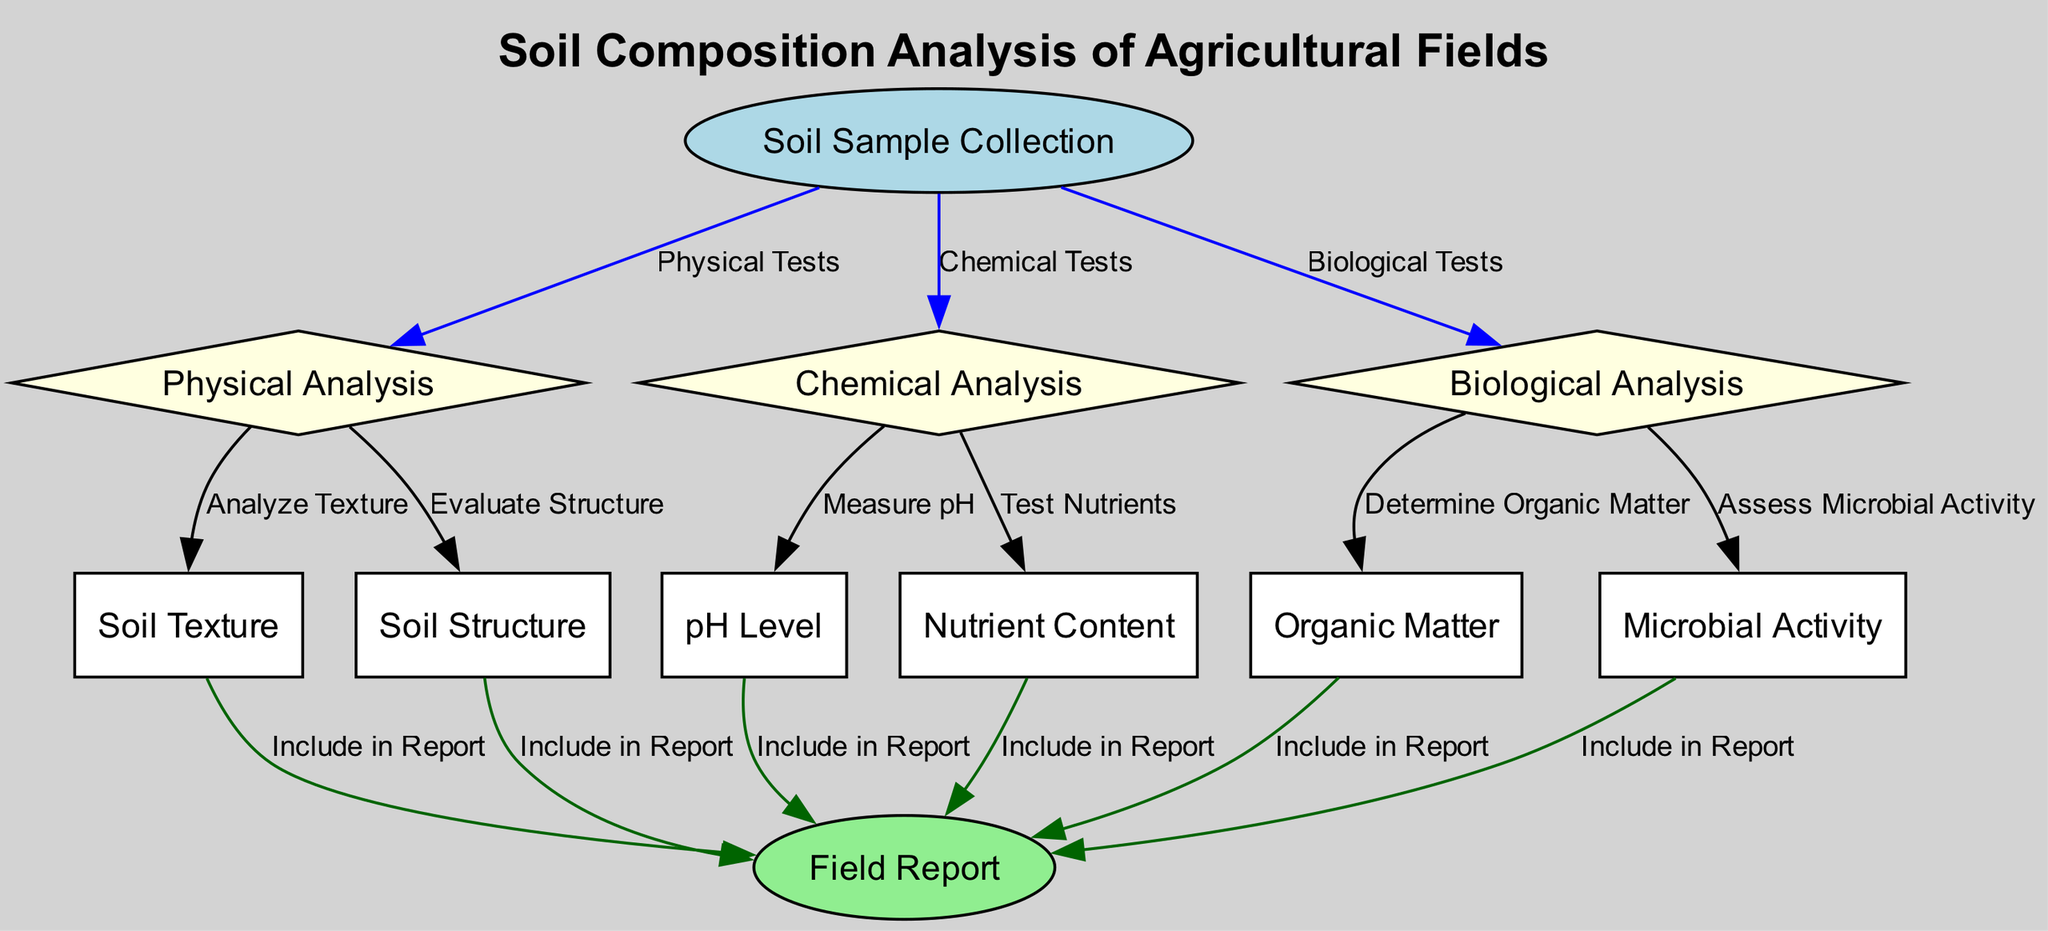What is the first step in soil composition analysis? The first node in the diagram is "Soil Sample Collection," indicating that collecting a soil sample is the initial step before any analysis takes place.
Answer: Soil Sample Collection How many types of analysis are performed on soil samples? The diagram indicates three types of analysis: Physical Analysis, Chemical Analysis, and Biological Analysis, linking them directly to the Soil Sample Collection.
Answer: Three Which analysis includes the evaluation of soil texture? The "Physical Analysis" node connects to "Soil Texture," showing that texture evaluation is part of the physical analysis.
Answer: Physical Analysis What factors are assessed in the biological analysis? The biological analysis evaluates both "Organic Matter" and "Microbial Activity," which are the connected nodes under Biological Analysis.
Answer: Organic Matter and Microbial Activity What kind of tests fall under chemical analysis? The chemical analysis involves "Measure pH" and "Test Nutrients," which are directly linked to the Chemical Analysis node.
Answer: Measure pH and Test Nutrients Which nodes lead to the field report? The nodes that lead to the Field Report are "Soil Texture," "Soil Structure," "pH Level," "Nutrient Content," "Organic Matter," and "Microbial Activity," all interconnected to the Field Report node.
Answer: Soil Texture, Soil Structure, pH Level, Nutrient Content, Organic Matter, Microbial Activity How many edges connect to the field report? Counting the edges leading to the Field Report from different nodes shows there are six connections represented in the diagram.
Answer: Six What color represents the soil sample collection node? The "Soil Sample Collection" node is displayed in light blue, which differentiates it from analyzing nodes and the field report.
Answer: Light blue What type of diagram is this? This is a textbook diagram illustrating the flow of processes involved in soil composition analysis, showcasing the steps and their relationships.
Answer: Textbook Diagram 